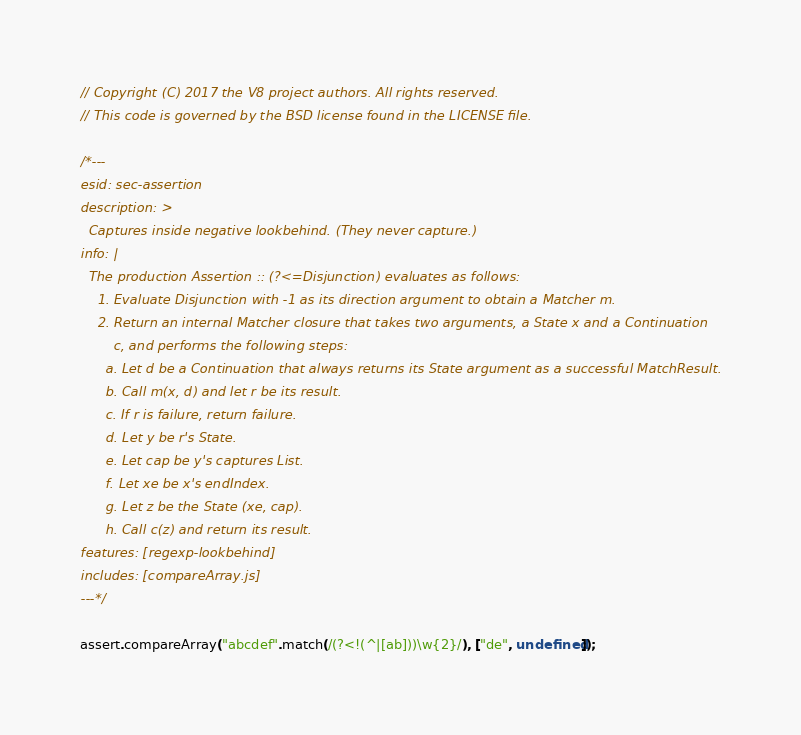<code> <loc_0><loc_0><loc_500><loc_500><_JavaScript_>// Copyright (C) 2017 the V8 project authors. All rights reserved.
// This code is governed by the BSD license found in the LICENSE file.

/*---
esid: sec-assertion
description: >
  Captures inside negative lookbehind. (They never capture.)
info: |
  The production Assertion :: (?<=Disjunction) evaluates as follows:
    1. Evaluate Disjunction with -1 as its direction argument to obtain a Matcher m.
    2. Return an internal Matcher closure that takes two arguments, a State x and a Continuation
        c, and performs the following steps:
      a. Let d be a Continuation that always returns its State argument as a successful MatchResult.
      b. Call m(x, d) and let r be its result.
      c. If r is failure, return failure.
      d. Let y be r's State.
      e. Let cap be y's captures List.
      f. Let xe be x's endIndex.
      g. Let z be the State (xe, cap).
      h. Call c(z) and return its result.
features: [regexp-lookbehind]
includes: [compareArray.js]
---*/

assert.compareArray("abcdef".match(/(?<!(^|[ab]))\w{2}/), ["de", undefined]);
</code> 